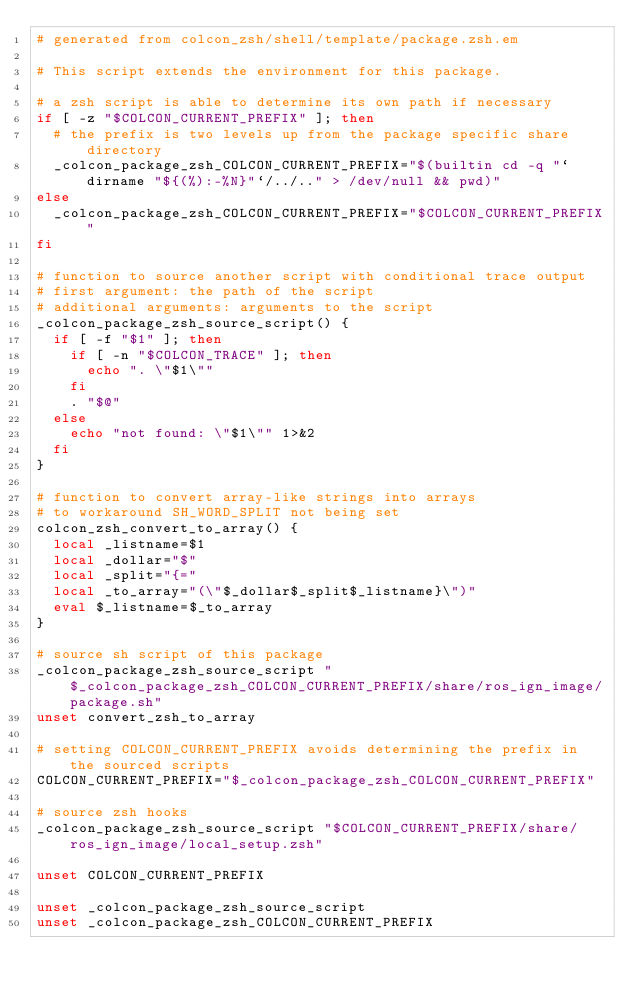Convert code to text. <code><loc_0><loc_0><loc_500><loc_500><_Bash_># generated from colcon_zsh/shell/template/package.zsh.em

# This script extends the environment for this package.

# a zsh script is able to determine its own path if necessary
if [ -z "$COLCON_CURRENT_PREFIX" ]; then
  # the prefix is two levels up from the package specific share directory
  _colcon_package_zsh_COLCON_CURRENT_PREFIX="$(builtin cd -q "`dirname "${(%):-%N}"`/../.." > /dev/null && pwd)"
else
  _colcon_package_zsh_COLCON_CURRENT_PREFIX="$COLCON_CURRENT_PREFIX"
fi

# function to source another script with conditional trace output
# first argument: the path of the script
# additional arguments: arguments to the script
_colcon_package_zsh_source_script() {
  if [ -f "$1" ]; then
    if [ -n "$COLCON_TRACE" ]; then
      echo ". \"$1\""
    fi
    . "$@"
  else
    echo "not found: \"$1\"" 1>&2
  fi
}

# function to convert array-like strings into arrays
# to workaround SH_WORD_SPLIT not being set
colcon_zsh_convert_to_array() {
  local _listname=$1
  local _dollar="$"
  local _split="{="
  local _to_array="(\"$_dollar$_split$_listname}\")"
  eval $_listname=$_to_array
}

# source sh script of this package
_colcon_package_zsh_source_script "$_colcon_package_zsh_COLCON_CURRENT_PREFIX/share/ros_ign_image/package.sh"
unset convert_zsh_to_array

# setting COLCON_CURRENT_PREFIX avoids determining the prefix in the sourced scripts
COLCON_CURRENT_PREFIX="$_colcon_package_zsh_COLCON_CURRENT_PREFIX"

# source zsh hooks
_colcon_package_zsh_source_script "$COLCON_CURRENT_PREFIX/share/ros_ign_image/local_setup.zsh"

unset COLCON_CURRENT_PREFIX

unset _colcon_package_zsh_source_script
unset _colcon_package_zsh_COLCON_CURRENT_PREFIX
</code> 